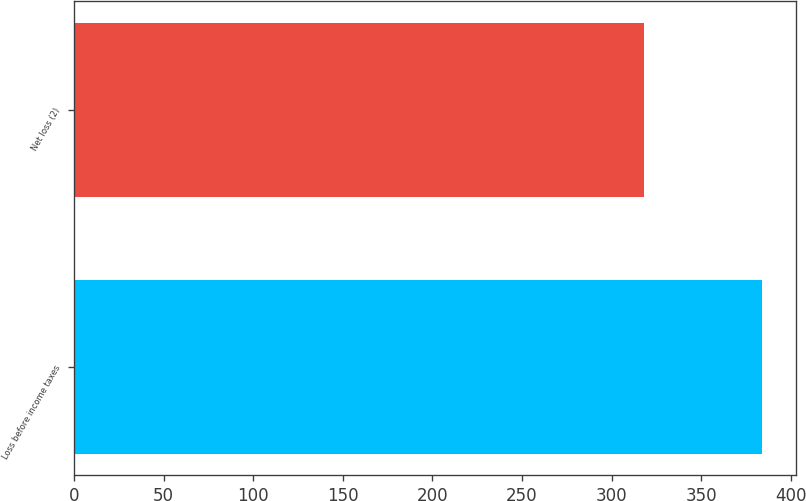<chart> <loc_0><loc_0><loc_500><loc_500><bar_chart><fcel>Loss before income taxes<fcel>Net loss (2)<nl><fcel>384<fcel>318<nl></chart> 